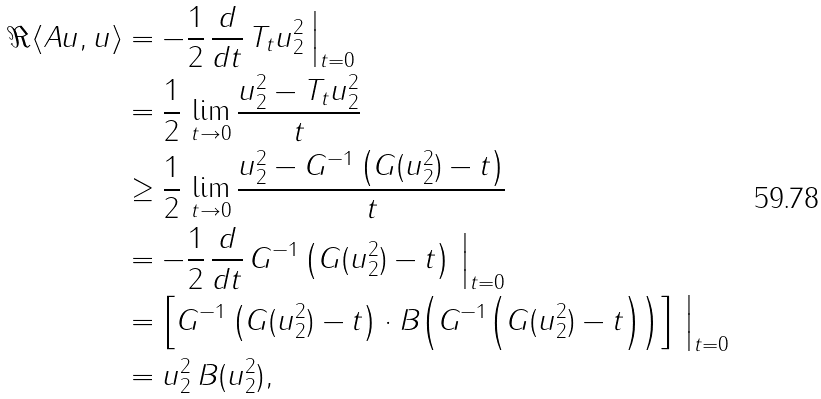Convert formula to latex. <formula><loc_0><loc_0><loc_500><loc_500>\Re \langle A u , u \rangle & = - \frac { 1 } { 2 } \, \frac { d } { d t } \, \| T _ { t } u \| _ { 2 } ^ { 2 } \, \Big | _ { t = 0 } \\ & = \frac { 1 } { 2 } \, \lim _ { t \to 0 } \frac { \| u \| _ { 2 } ^ { 2 } - \| T _ { t } u \| _ { 2 } ^ { 2 } } { t } \\ & \geq \frac { 1 } { 2 } \, \lim _ { t \to 0 } \frac { \| u \| _ { 2 } ^ { 2 } - G ^ { - 1 } \left ( G ( \| u \| _ { 2 } ^ { 2 } ) - t \right ) } { t } \\ & = - \frac { 1 } { 2 } \, \frac { d } { d t } \, G ^ { - 1 } \left ( G ( \| u \| _ { 2 } ^ { 2 } ) - t \right ) \, \Big | _ { t = 0 } \\ & = \left [ G ^ { - 1 } \left ( G ( \| u \| _ { 2 } ^ { 2 } ) - t \right ) \cdot B \Big ( G ^ { - 1 } \Big ( G ( \| u \| _ { 2 } ^ { 2 } ) - t \Big ) \Big ) \right ] \, \Big | _ { t = 0 } \\ & = \| u \| _ { 2 } ^ { 2 } \, B ( \| u \| _ { 2 } ^ { 2 } ) ,</formula> 